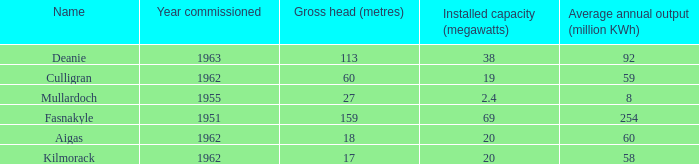What is the typical yearly production for culligran power station with a maximum capacity under 19? None. 